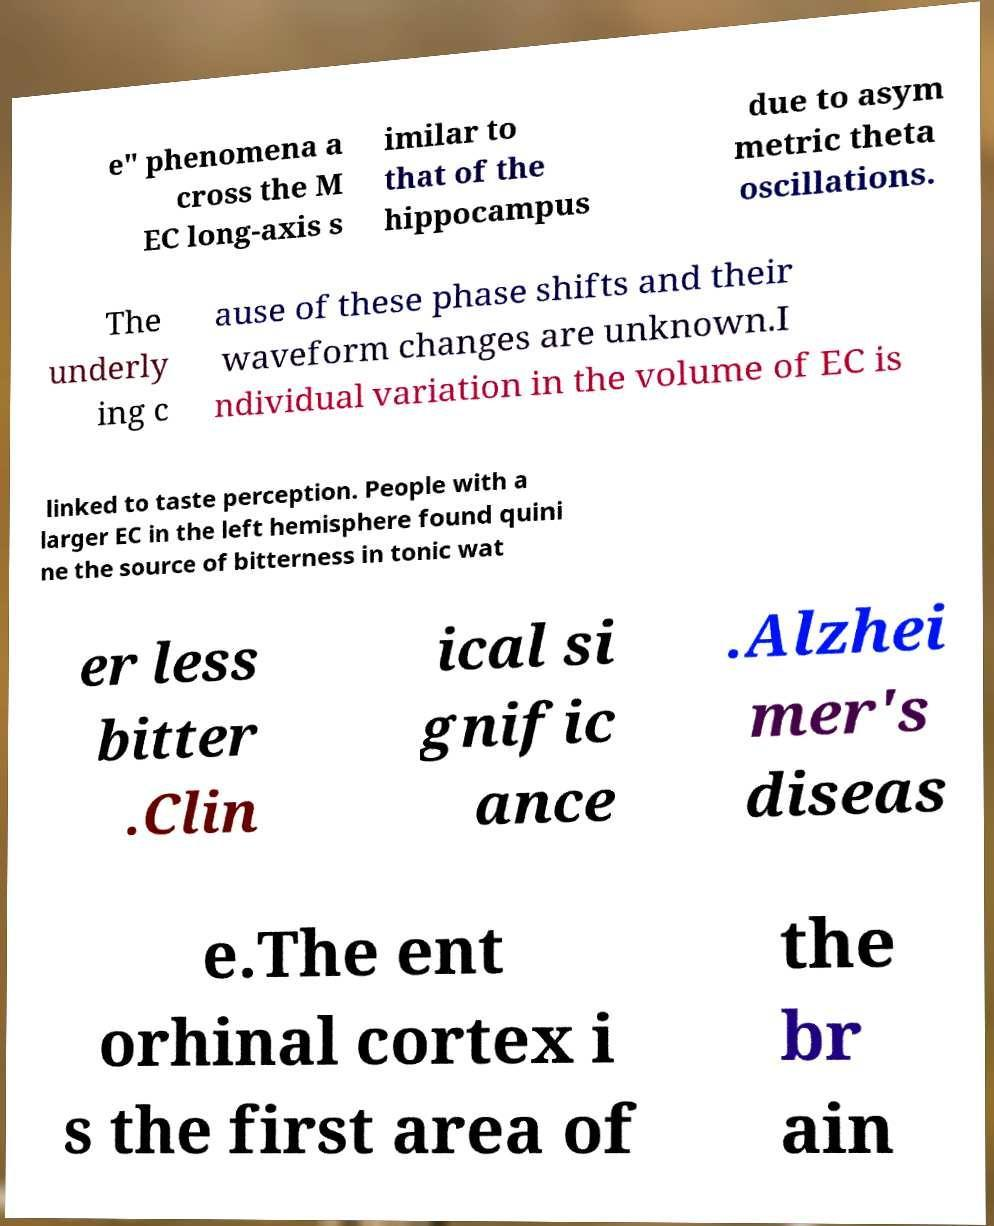Can you read and provide the text displayed in the image?This photo seems to have some interesting text. Can you extract and type it out for me? e" phenomena a cross the M EC long-axis s imilar to that of the hippocampus due to asym metric theta oscillations. The underly ing c ause of these phase shifts and their waveform changes are unknown.I ndividual variation in the volume of EC is linked to taste perception. People with a larger EC in the left hemisphere found quini ne the source of bitterness in tonic wat er less bitter .Clin ical si gnific ance .Alzhei mer's diseas e.The ent orhinal cortex i s the first area of the br ain 